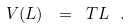Convert formula to latex. <formula><loc_0><loc_0><loc_500><loc_500>V ( L ) \ = \ T L \ .</formula> 